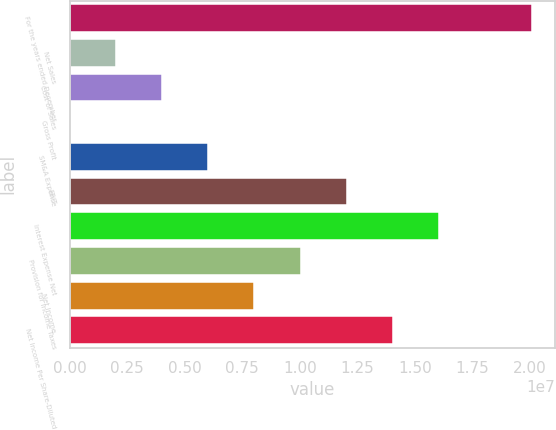<chart> <loc_0><loc_0><loc_500><loc_500><bar_chart><fcel>For the years ended December<fcel>Net Sales<fcel>Cost of Sales<fcel>Gross Profit<fcel>SM&A Expense<fcel>EBIT<fcel>Interest Expense Net<fcel>Provision for Income Taxes<fcel>Net Income<fcel>Net Income Per Share-Diluted<nl><fcel>2.0062e+07<fcel>2.0062e+06<fcel>4.0124e+06<fcel>0.2<fcel>6.0186e+06<fcel>1.20372e+07<fcel>1.60496e+07<fcel>1.0031e+07<fcel>8.0248e+06<fcel>1.40434e+07<nl></chart> 